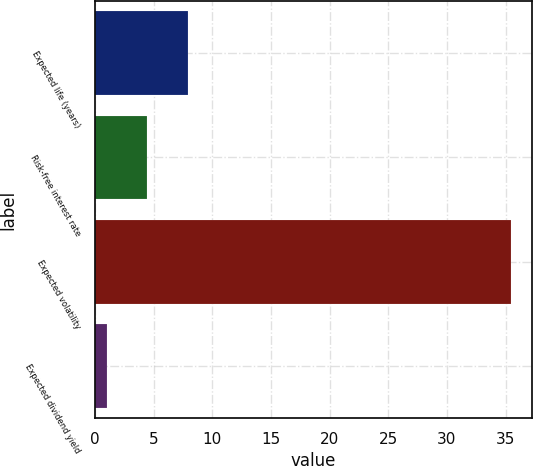Convert chart. <chart><loc_0><loc_0><loc_500><loc_500><bar_chart><fcel>Expected life (years)<fcel>Risk-free interest rate<fcel>Expected volatility<fcel>Expected dividend yield<nl><fcel>7.9<fcel>4.45<fcel>35.5<fcel>1<nl></chart> 